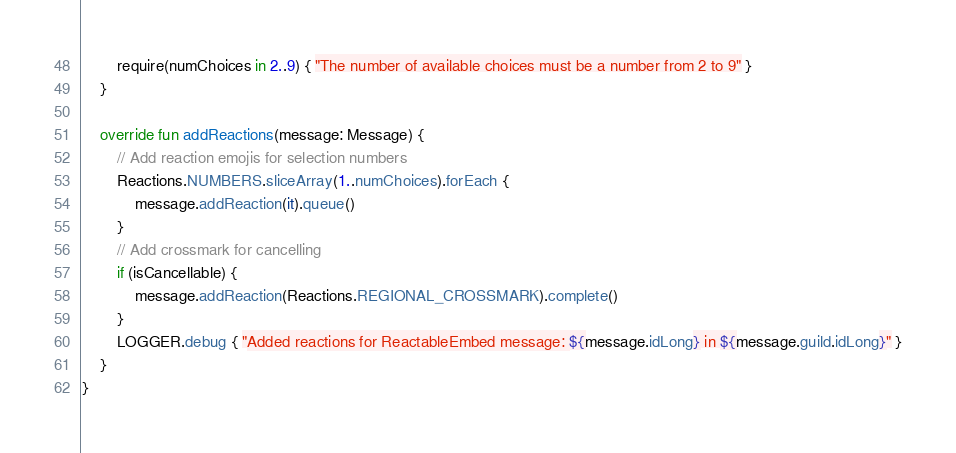Convert code to text. <code><loc_0><loc_0><loc_500><loc_500><_Kotlin_>        require(numChoices in 2..9) { "The number of available choices must be a number from 2 to 9" }
    }

    override fun addReactions(message: Message) {
        // Add reaction emojis for selection numbers
        Reactions.NUMBERS.sliceArray(1..numChoices).forEach {
            message.addReaction(it).queue()
        }
        // Add crossmark for cancelling
        if (isCancellable) {
            message.addReaction(Reactions.REGIONAL_CROSSMARK).complete()
        }
        LOGGER.debug { "Added reactions for ReactableEmbed message: ${message.idLong} in ${message.guild.idLong}" }
    }
}
</code> 